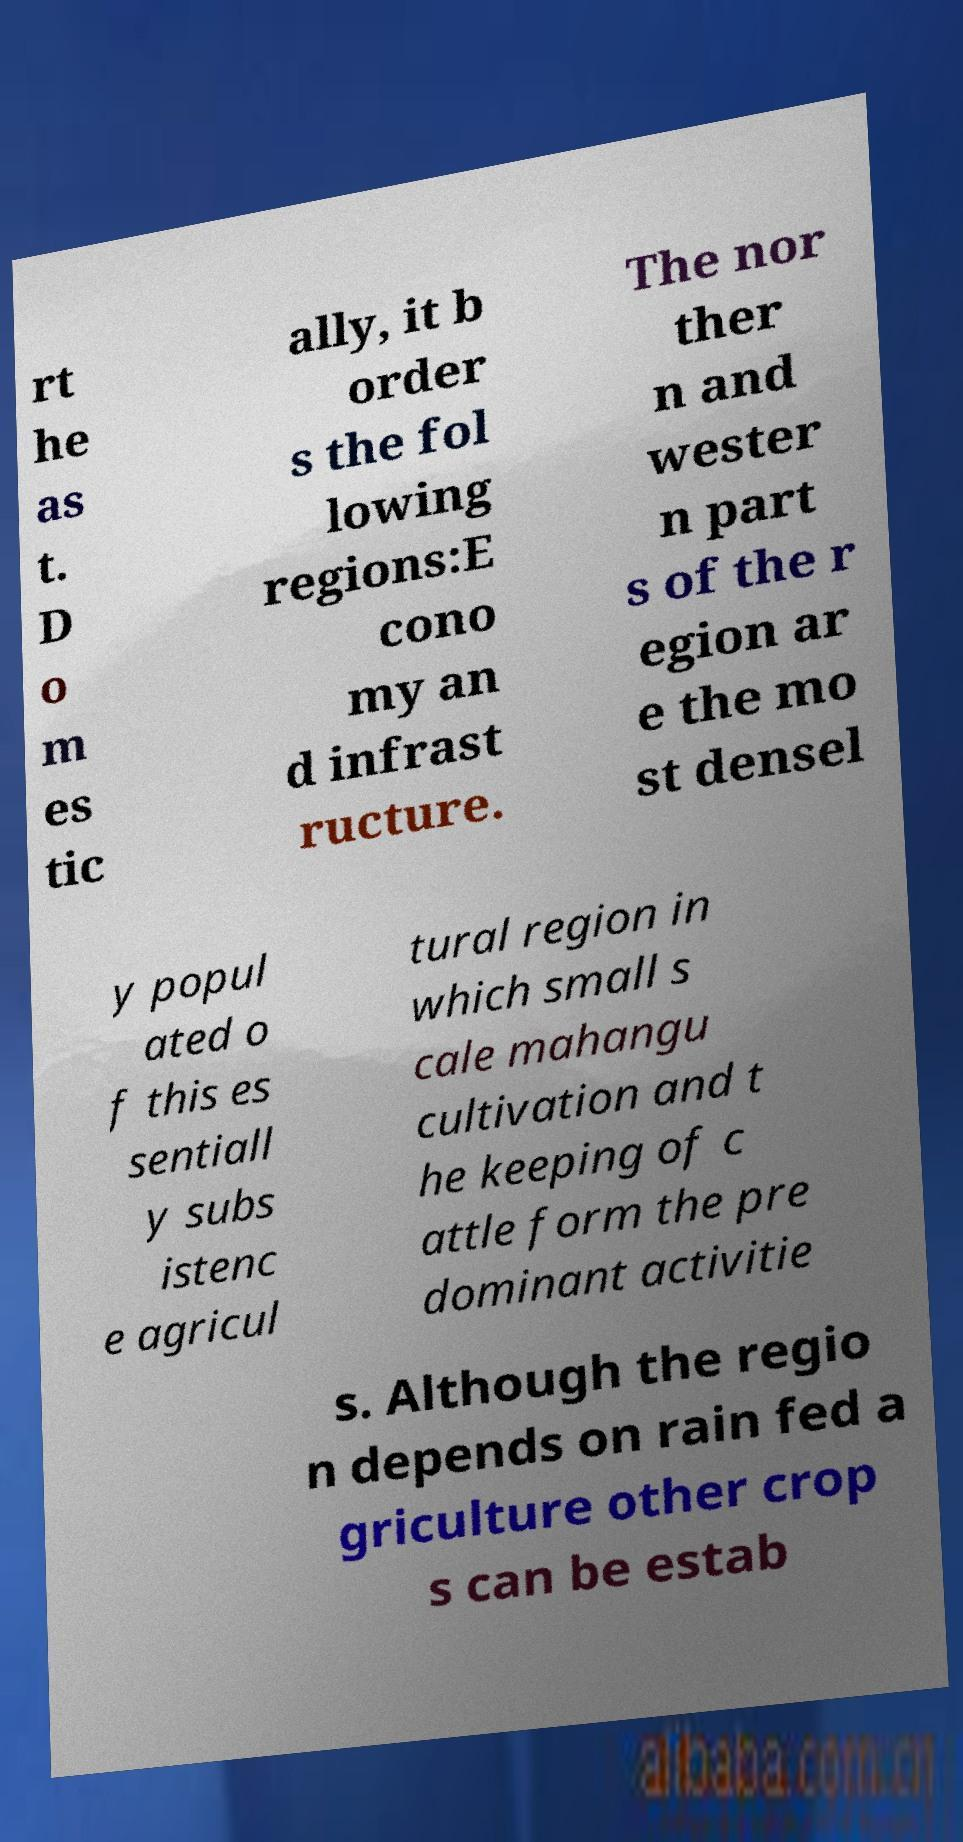What messages or text are displayed in this image? I need them in a readable, typed format. rt he as t. D o m es tic ally, it b order s the fol lowing regions:E cono my an d infrast ructure. The nor ther n and wester n part s of the r egion ar e the mo st densel y popul ated o f this es sentiall y subs istenc e agricul tural region in which small s cale mahangu cultivation and t he keeping of c attle form the pre dominant activitie s. Although the regio n depends on rain fed a griculture other crop s can be estab 